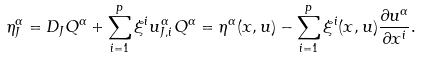<formula> <loc_0><loc_0><loc_500><loc_500>\eta _ { J } ^ { \alpha } = D _ { J } Q ^ { \alpha } + \sum _ { i = 1 } ^ { p } \xi ^ { i } u _ { J , i } ^ { \alpha } Q ^ { \alpha } = \eta ^ { \alpha } ( x , u ) - \sum _ { i = 1 } ^ { p } \xi ^ { i } ( x , u ) \frac { \partial u ^ { \alpha } } { \partial x ^ { i } } .</formula> 